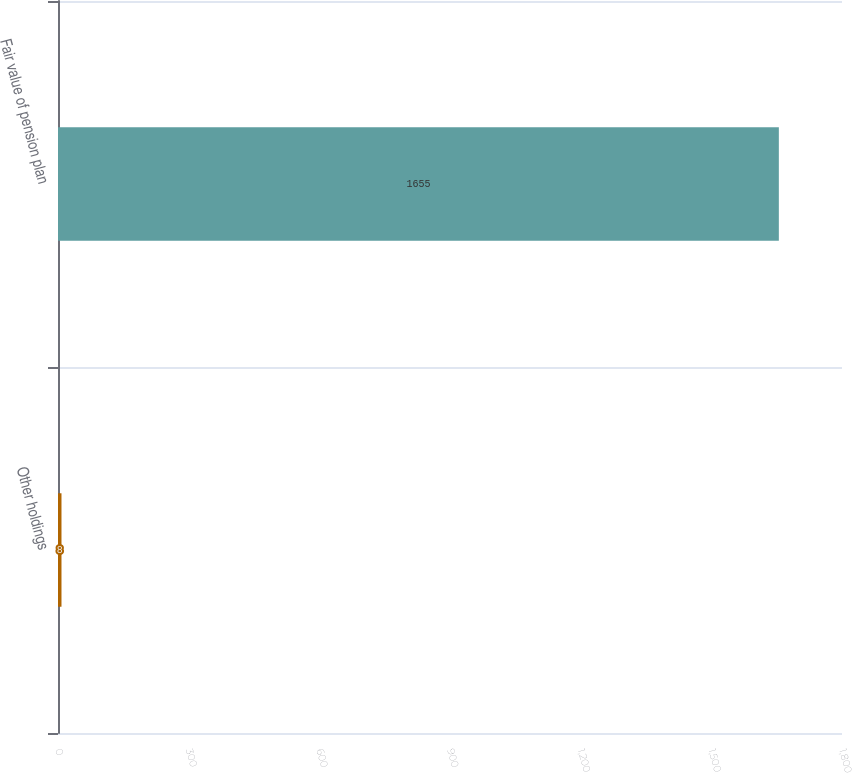<chart> <loc_0><loc_0><loc_500><loc_500><bar_chart><fcel>Other holdings<fcel>Fair value of pension plan<nl><fcel>8<fcel>1655<nl></chart> 